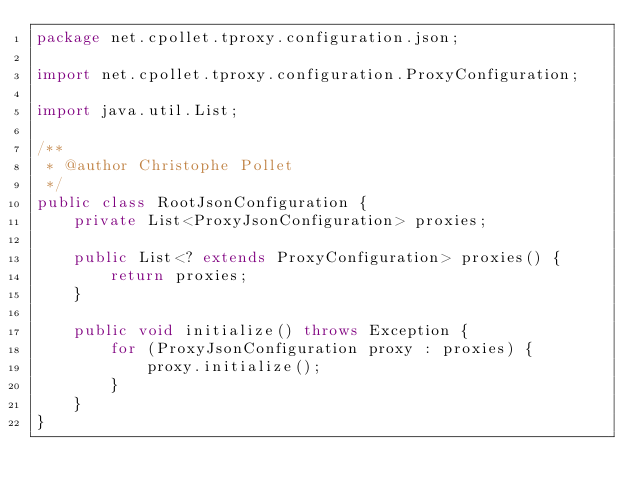Convert code to text. <code><loc_0><loc_0><loc_500><loc_500><_Java_>package net.cpollet.tproxy.configuration.json;

import net.cpollet.tproxy.configuration.ProxyConfiguration;

import java.util.List;

/**
 * @author Christophe Pollet
 */
public class RootJsonConfiguration {
    private List<ProxyJsonConfiguration> proxies;

    public List<? extends ProxyConfiguration> proxies() {
        return proxies;
    }

    public void initialize() throws Exception {
        for (ProxyJsonConfiguration proxy : proxies) {
            proxy.initialize();
        }
    }
}
</code> 